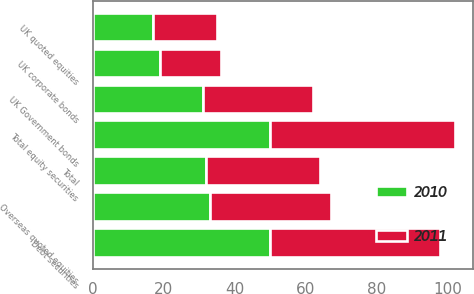Convert chart. <chart><loc_0><loc_0><loc_500><loc_500><stacked_bar_chart><ecel><fcel>UK quoted equities<fcel>Overseas quoted equities<fcel>Total equity securities<fcel>UK Government bonds<fcel>UK corporate bonds<fcel>Debt securities<fcel>Total<nl><fcel>2010<fcel>17<fcel>33<fcel>50<fcel>31<fcel>19<fcel>50<fcel>32<nl><fcel>2011<fcel>18<fcel>34<fcel>52<fcel>31<fcel>17<fcel>48<fcel>32<nl></chart> 